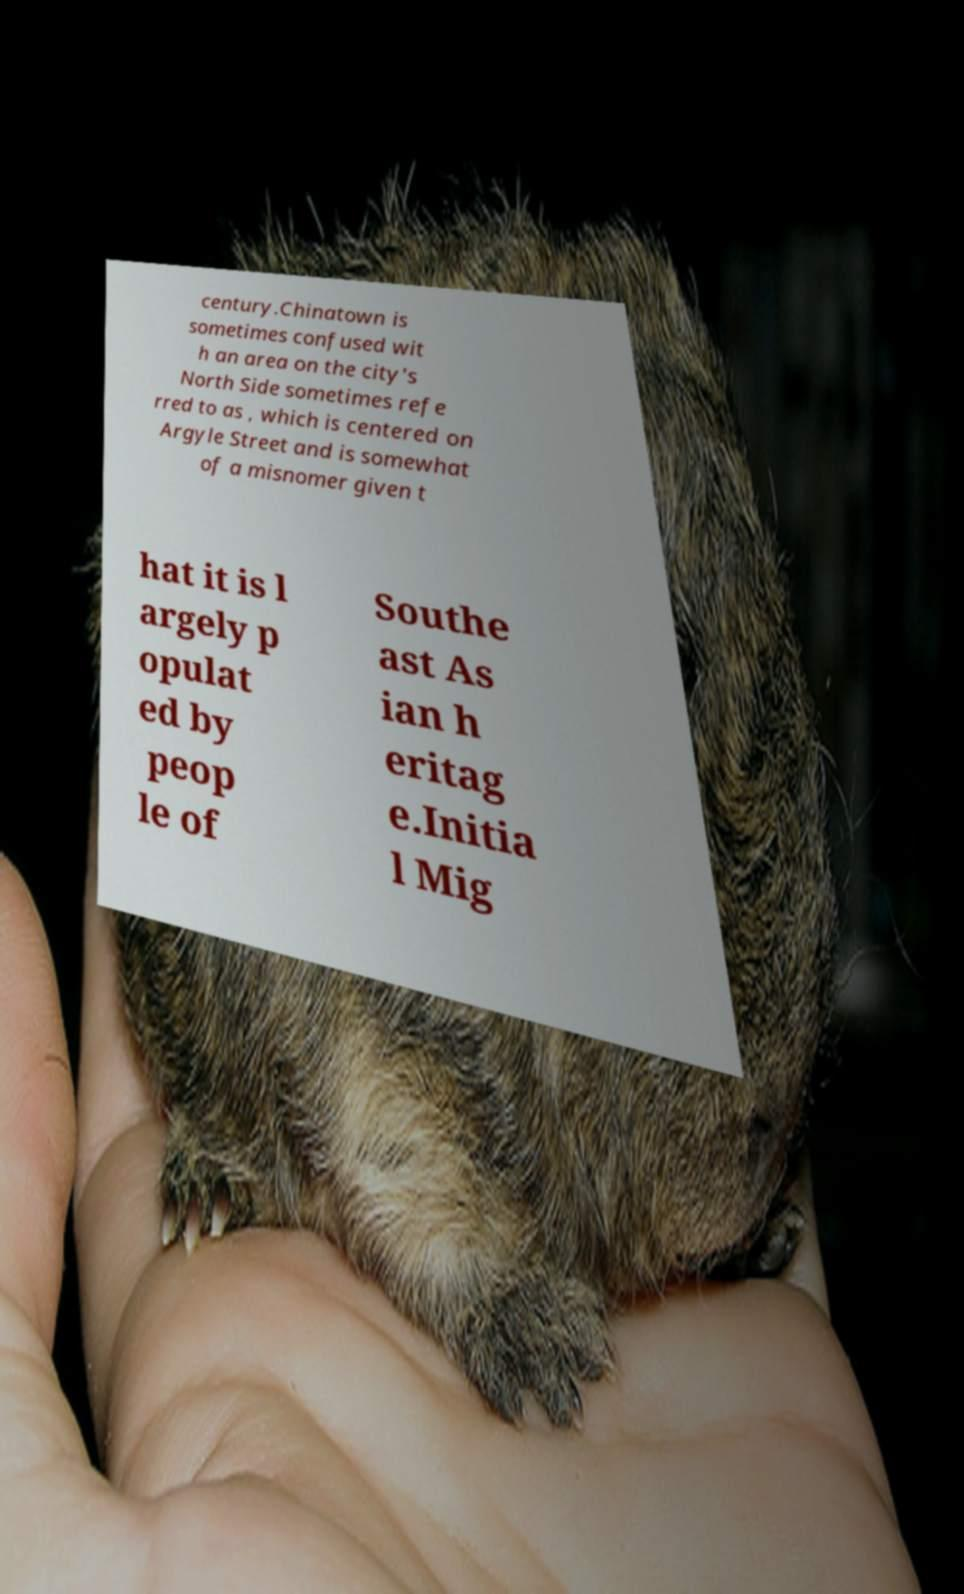What messages or text are displayed in this image? I need them in a readable, typed format. century.Chinatown is sometimes confused wit h an area on the city's North Side sometimes refe rred to as , which is centered on Argyle Street and is somewhat of a misnomer given t hat it is l argely p opulat ed by peop le of Southe ast As ian h eritag e.Initia l Mig 